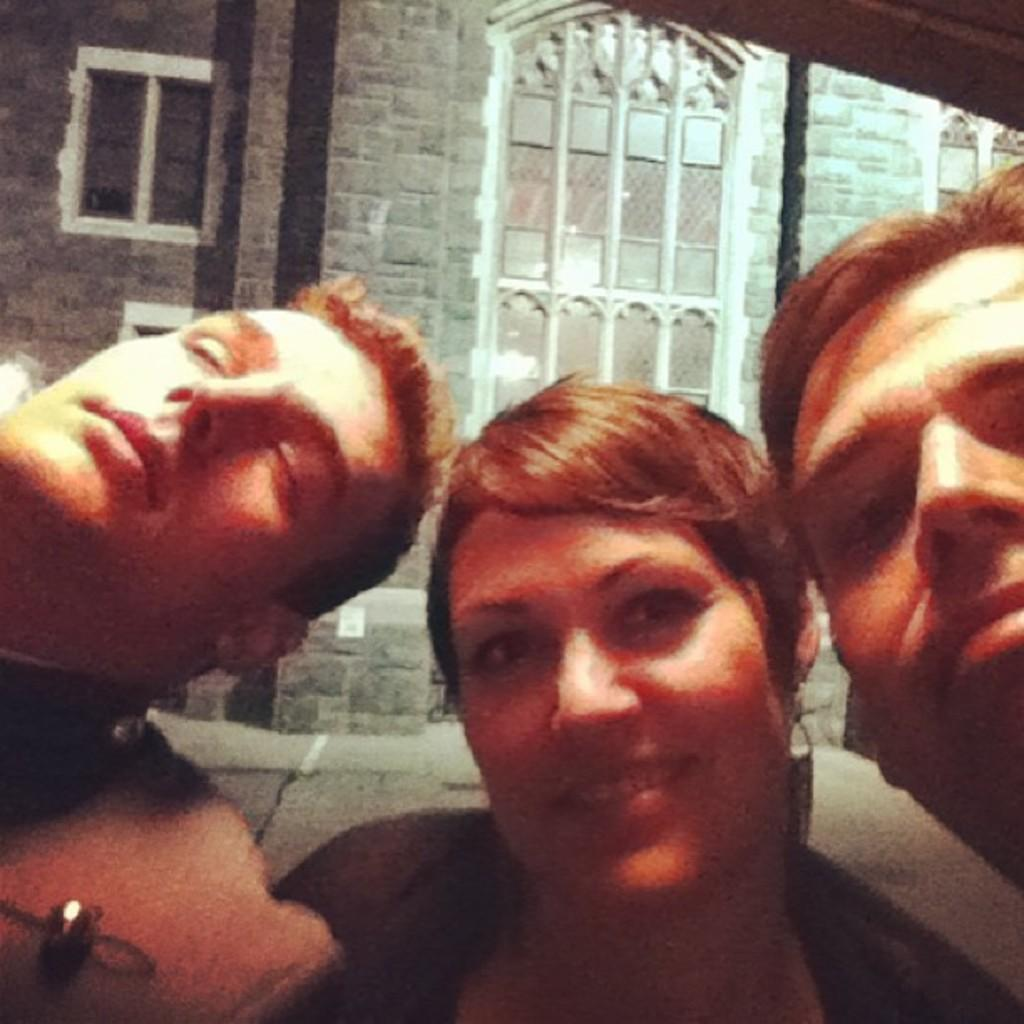How many people are in the image? There are two men and a woman in the image. What is the woman doing in the image? The woman is in the middle and is smiling. What can be seen in the background of the image? There is a wall in the background of the image. What features are present on the wall? The wall has windows and other objects visible on it. What type of process is being carried out with the bucket on the woman's wrist in the image? There is no bucket or wrist activity present in the image. 